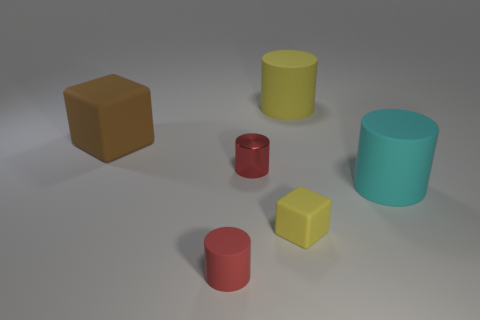There is a cylinder that is both behind the small yellow matte thing and left of the big yellow rubber object; what is its size?
Keep it short and to the point. Small. Are there more cubes behind the tiny yellow block than big yellow rubber balls?
Offer a very short reply. Yes. How many cylinders are either red matte things or large rubber objects?
Offer a very short reply. 3. There is a large thing that is both in front of the big yellow rubber cylinder and right of the brown rubber block; what shape is it?
Your answer should be compact. Cylinder. Is the number of small yellow rubber blocks behind the cyan rubber object the same as the number of large cyan objects in front of the tiny red rubber object?
Offer a very short reply. Yes. How many objects are large objects or yellow objects?
Keep it short and to the point. 4. There is a rubber cube that is the same size as the red shiny object; what is its color?
Offer a terse response. Yellow. How many things are either big rubber things that are behind the big brown block or cylinders that are in front of the yellow matte cylinder?
Your answer should be compact. 4. Are there an equal number of large cyan things on the right side of the cyan cylinder and brown rubber blocks?
Make the answer very short. No. There is a yellow matte object that is behind the cyan thing; is its size the same as the red object in front of the red metal cylinder?
Your answer should be very brief. No. 